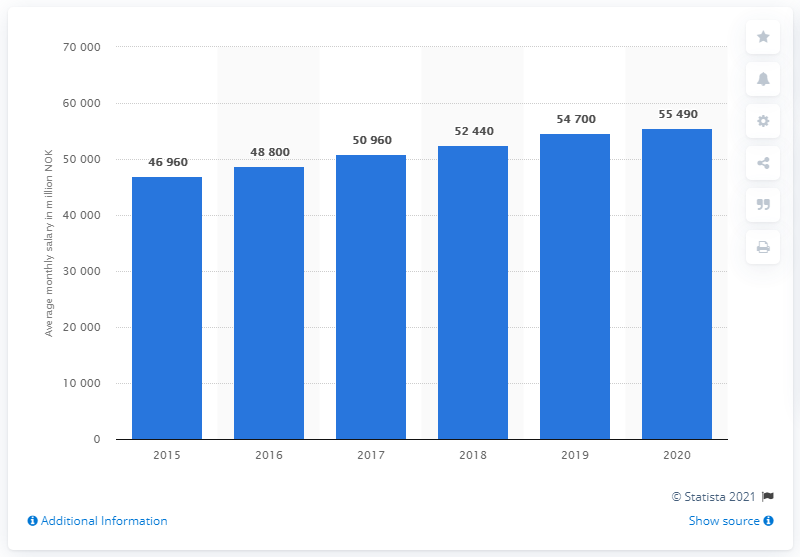Draw attention to some important aspects in this diagram. The average monthly salary of veterinarians in Norway in 2020 was approximately 55,490 U.S. dollars. 